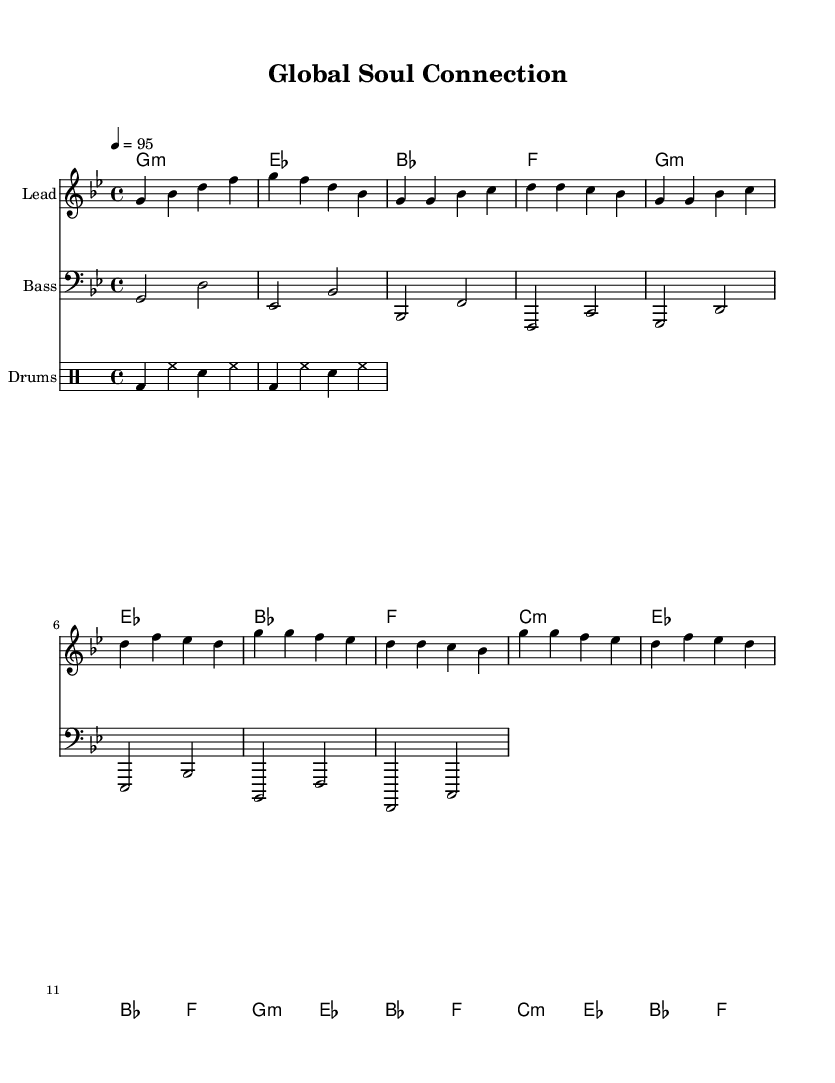What is the key signature of this music? The key signature is indicated at the beginning of the staff, showing two flats, which corresponds to G minor.
Answer: G minor What is the time signature of this music? The time signature is displayed at the beginning and is shown as 4/4, meaning there are four beats in each measure.
Answer: 4/4 What is the tempo marking of this music? The tempo marking is given in beats per minute and is set to 95, indicating the speed of the piece.
Answer: 95 How many measures are in the verse section? The verse section is broken down into sets of bars, and counting the measures in the verse reveals a total of four measures present.
Answer: 4 What instruments are included in this score? By examining the score layout, we observe several parts: a lead instrument, bass, and drums make up the ensemble of this piece.
Answer: Lead, Bass, Drums What is the primary theme expressed in the lyrics? The lyrics express the interconnectedness of cultures across the globe, emphasizing unity and shared experiences through music.
Answer: Global connectedness How do the chord progressions relate to the rhythm and blues genre? The chord progression follows a pattern that is common in rhythm and blues music, using minor chords and resolving in a way that creates emotional depth.
Answer: Minor chord progression 